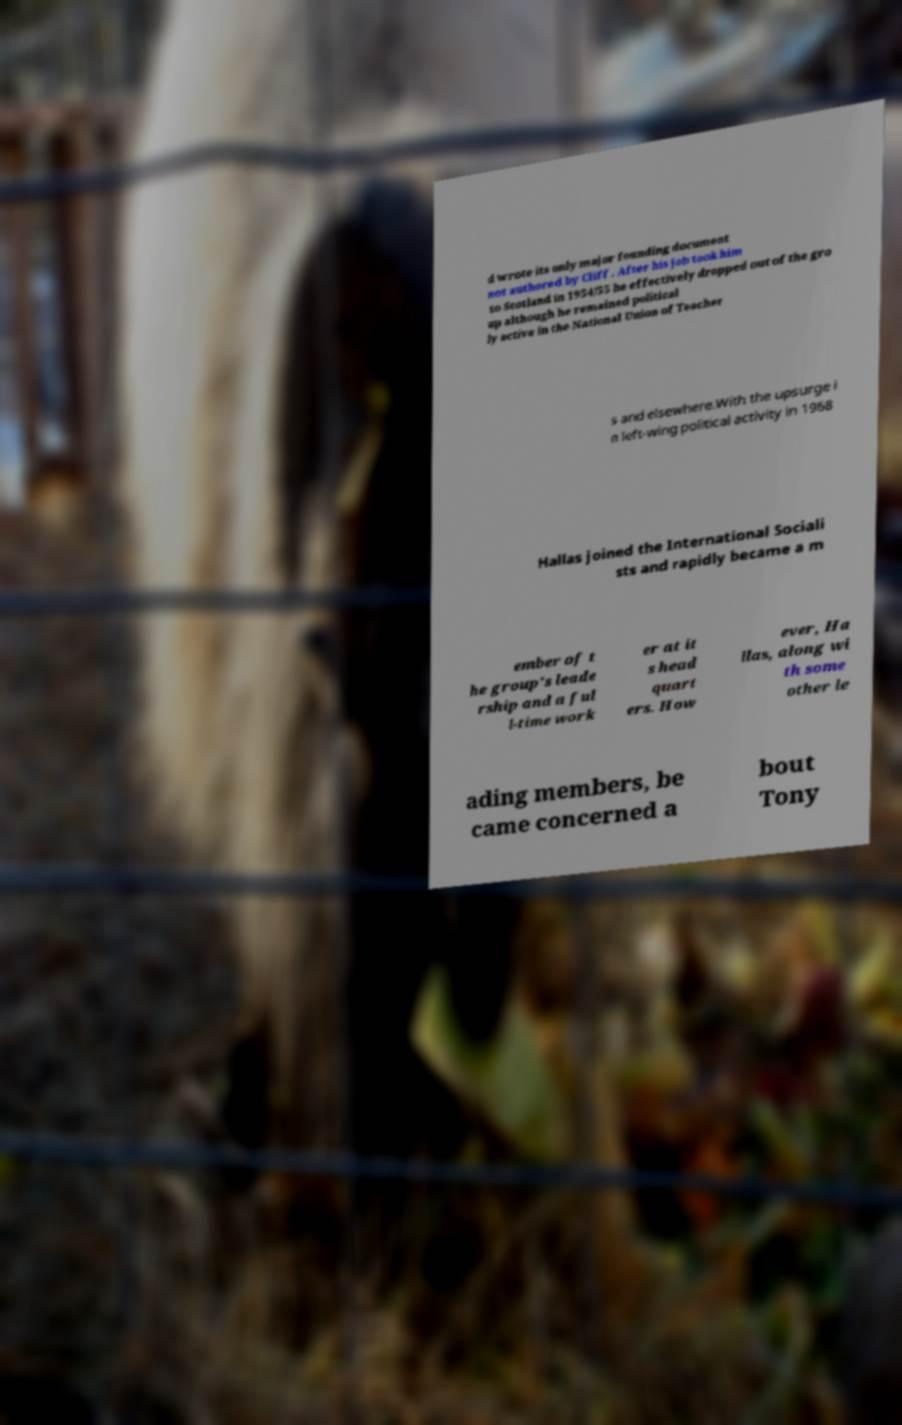I need the written content from this picture converted into text. Can you do that? d wrote its only major founding document not authored by Cliff . After his job took him to Scotland in 1954/55 he effectively dropped out of the gro up although he remained political ly active in the National Union of Teacher s and elsewhere.With the upsurge i n left-wing political activity in 1968 Hallas joined the International Sociali sts and rapidly became a m ember of t he group's leade rship and a ful l-time work er at it s head quart ers. How ever, Ha llas, along wi th some other le ading members, be came concerned a bout Tony 